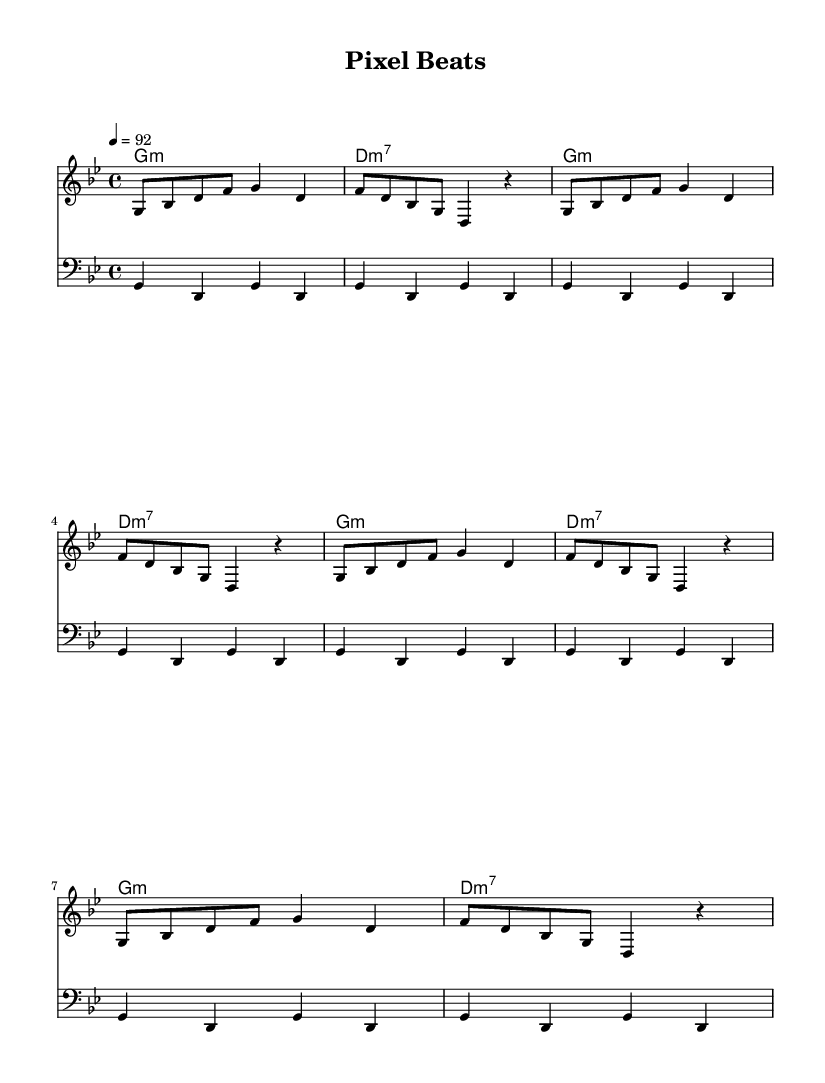What is the key signature of this music? The key signature is indicated at the beginning of the piece, showing two flats. This denotes the key of G minor.
Answer: G minor What is the time signature of this music? The time signature appears at the start of the sheet music as 4/4, indicating four beats per measure with a quarter note receiving one beat.
Answer: 4/4 What is the tempo marking of this piece? The tempo marking is shown at the beginning of the score, stating "4=92," which indicates that quarter notes are played at a speed of 92 beats per minute.
Answer: 92 How many bars are in the verse section of the melody? The melody section has a repetitive structure for the verse, with the first four bars repeated a total of two times, which results in eight bars for the verse.
Answer: 8 Which chords are used in the harmony section? Looking at the harmony part, the chords are shown as G minor and D minor 7, both of which are repeated throughout the introduction and verse sections.
Answer: G minor, D minor 7 What is the significance of using "g4 d g d" in the bass section? This repetitive bass line of "g4 d g d" forms the foundation of the piece, emphasizing the root note of G while adding rhythmic stability, common in hip-hop.
Answer: Foundation What type of samples and effects might be represented in this hip-hop track? While not explicitly shown on the sheet music, hip-hop often incorporates electronic beats, vocal chops, or video game sound effects that could mirror the melody's electronic style in "Pixel Beats."
Answer: Video game samples 